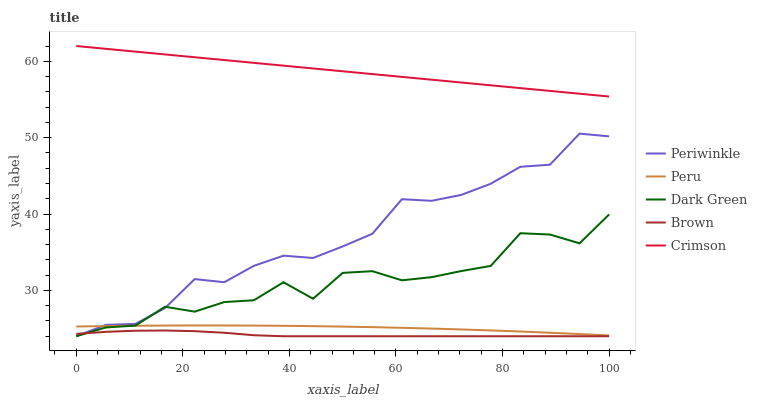Does Brown have the minimum area under the curve?
Answer yes or no. Yes. Does Crimson have the maximum area under the curve?
Answer yes or no. Yes. Does Periwinkle have the minimum area under the curve?
Answer yes or no. No. Does Periwinkle have the maximum area under the curve?
Answer yes or no. No. Is Crimson the smoothest?
Answer yes or no. Yes. Is Dark Green the roughest?
Answer yes or no. Yes. Is Brown the smoothest?
Answer yes or no. No. Is Brown the roughest?
Answer yes or no. No. Does Brown have the lowest value?
Answer yes or no. Yes. Does Peru have the lowest value?
Answer yes or no. No. Does Crimson have the highest value?
Answer yes or no. Yes. Does Periwinkle have the highest value?
Answer yes or no. No. Is Periwinkle less than Crimson?
Answer yes or no. Yes. Is Peru greater than Brown?
Answer yes or no. Yes. Does Dark Green intersect Peru?
Answer yes or no. Yes. Is Dark Green less than Peru?
Answer yes or no. No. Is Dark Green greater than Peru?
Answer yes or no. No. Does Periwinkle intersect Crimson?
Answer yes or no. No. 